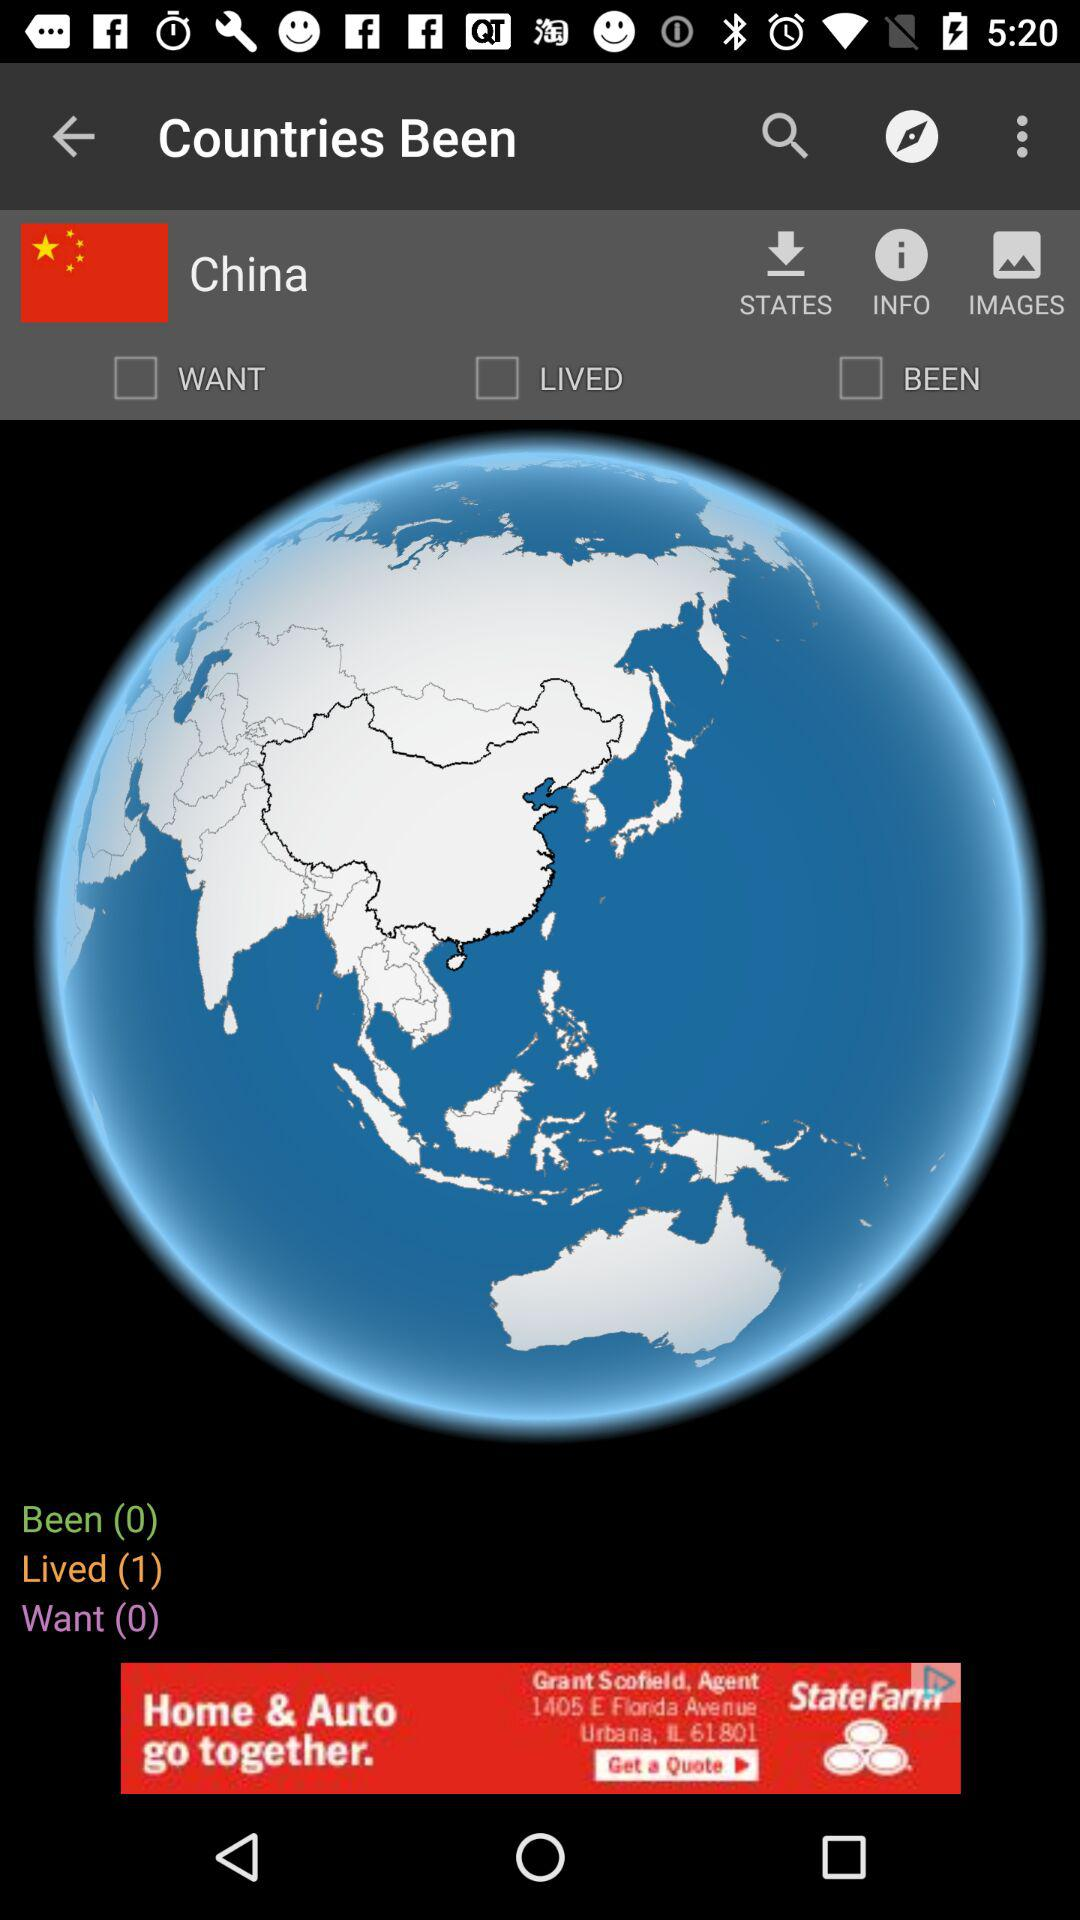What is the application name? The application name is "Countries Been". 